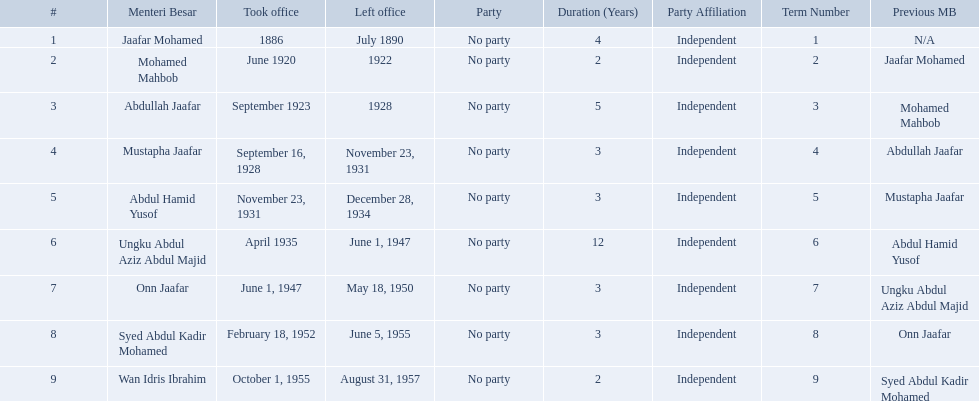What was the date the last person on the list left office? August 31, 1957. 